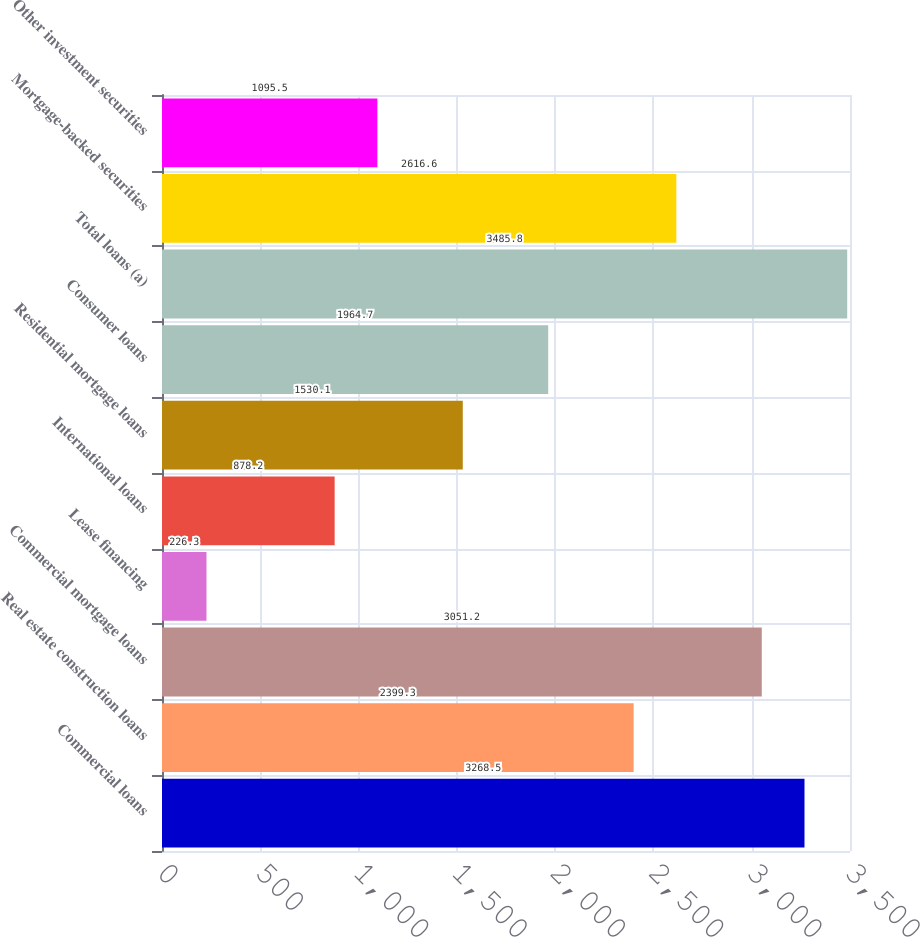Convert chart to OTSL. <chart><loc_0><loc_0><loc_500><loc_500><bar_chart><fcel>Commercial loans<fcel>Real estate construction loans<fcel>Commercial mortgage loans<fcel>Lease financing<fcel>International loans<fcel>Residential mortgage loans<fcel>Consumer loans<fcel>Total loans (a)<fcel>Mortgage-backed securities<fcel>Other investment securities<nl><fcel>3268.5<fcel>2399.3<fcel>3051.2<fcel>226.3<fcel>878.2<fcel>1530.1<fcel>1964.7<fcel>3485.8<fcel>2616.6<fcel>1095.5<nl></chart> 